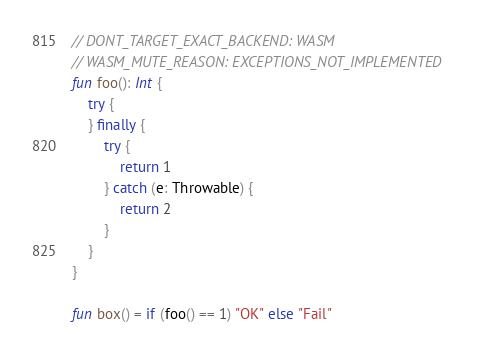Convert code to text. <code><loc_0><loc_0><loc_500><loc_500><_Kotlin_>// DONT_TARGET_EXACT_BACKEND: WASM
// WASM_MUTE_REASON: EXCEPTIONS_NOT_IMPLEMENTED
fun foo(): Int {
    try {
    } finally {
        try {
            return 1
        } catch (e: Throwable) {
            return 2
        }
    }
}

fun box() = if (foo() == 1) "OK" else "Fail"
</code> 